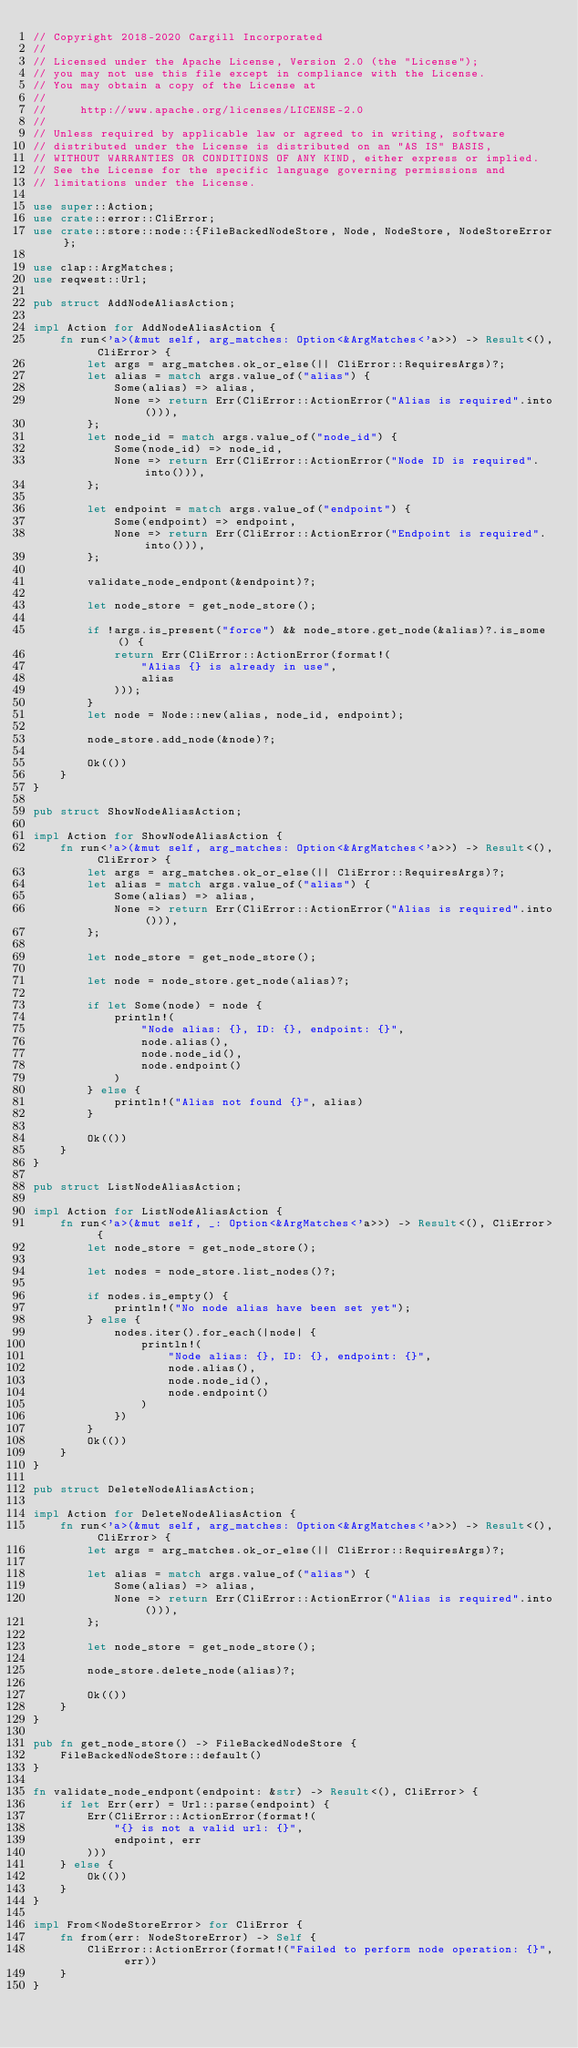<code> <loc_0><loc_0><loc_500><loc_500><_Rust_>// Copyright 2018-2020 Cargill Incorporated
//
// Licensed under the Apache License, Version 2.0 (the "License");
// you may not use this file except in compliance with the License.
// You may obtain a copy of the License at
//
//     http://www.apache.org/licenses/LICENSE-2.0
//
// Unless required by applicable law or agreed to in writing, software
// distributed under the License is distributed on an "AS IS" BASIS,
// WITHOUT WARRANTIES OR CONDITIONS OF ANY KIND, either express or implied.
// See the License for the specific language governing permissions and
// limitations under the License.

use super::Action;
use crate::error::CliError;
use crate::store::node::{FileBackedNodeStore, Node, NodeStore, NodeStoreError};

use clap::ArgMatches;
use reqwest::Url;

pub struct AddNodeAliasAction;

impl Action for AddNodeAliasAction {
    fn run<'a>(&mut self, arg_matches: Option<&ArgMatches<'a>>) -> Result<(), CliError> {
        let args = arg_matches.ok_or_else(|| CliError::RequiresArgs)?;
        let alias = match args.value_of("alias") {
            Some(alias) => alias,
            None => return Err(CliError::ActionError("Alias is required".into())),
        };
        let node_id = match args.value_of("node_id") {
            Some(node_id) => node_id,
            None => return Err(CliError::ActionError("Node ID is required".into())),
        };

        let endpoint = match args.value_of("endpoint") {
            Some(endpoint) => endpoint,
            None => return Err(CliError::ActionError("Endpoint is required".into())),
        };

        validate_node_endpont(&endpoint)?;

        let node_store = get_node_store();

        if !args.is_present("force") && node_store.get_node(&alias)?.is_some() {
            return Err(CliError::ActionError(format!(
                "Alias {} is already in use",
                alias
            )));
        }
        let node = Node::new(alias, node_id, endpoint);

        node_store.add_node(&node)?;

        Ok(())
    }
}

pub struct ShowNodeAliasAction;

impl Action for ShowNodeAliasAction {
    fn run<'a>(&mut self, arg_matches: Option<&ArgMatches<'a>>) -> Result<(), CliError> {
        let args = arg_matches.ok_or_else(|| CliError::RequiresArgs)?;
        let alias = match args.value_of("alias") {
            Some(alias) => alias,
            None => return Err(CliError::ActionError("Alias is required".into())),
        };

        let node_store = get_node_store();

        let node = node_store.get_node(alias)?;

        if let Some(node) = node {
            println!(
                "Node alias: {}, ID: {}, endpoint: {}",
                node.alias(),
                node.node_id(),
                node.endpoint()
            )
        } else {
            println!("Alias not found {}", alias)
        }

        Ok(())
    }
}

pub struct ListNodeAliasAction;

impl Action for ListNodeAliasAction {
    fn run<'a>(&mut self, _: Option<&ArgMatches<'a>>) -> Result<(), CliError> {
        let node_store = get_node_store();

        let nodes = node_store.list_nodes()?;

        if nodes.is_empty() {
            println!("No node alias have been set yet");
        } else {
            nodes.iter().for_each(|node| {
                println!(
                    "Node alias: {}, ID: {}, endpoint: {}",
                    node.alias(),
                    node.node_id(),
                    node.endpoint()
                )
            })
        }
        Ok(())
    }
}

pub struct DeleteNodeAliasAction;

impl Action for DeleteNodeAliasAction {
    fn run<'a>(&mut self, arg_matches: Option<&ArgMatches<'a>>) -> Result<(), CliError> {
        let args = arg_matches.ok_or_else(|| CliError::RequiresArgs)?;

        let alias = match args.value_of("alias") {
            Some(alias) => alias,
            None => return Err(CliError::ActionError("Alias is required".into())),
        };

        let node_store = get_node_store();

        node_store.delete_node(alias)?;

        Ok(())
    }
}

pub fn get_node_store() -> FileBackedNodeStore {
    FileBackedNodeStore::default()
}

fn validate_node_endpont(endpoint: &str) -> Result<(), CliError> {
    if let Err(err) = Url::parse(endpoint) {
        Err(CliError::ActionError(format!(
            "{} is not a valid url: {}",
            endpoint, err
        )))
    } else {
        Ok(())
    }
}

impl From<NodeStoreError> for CliError {
    fn from(err: NodeStoreError) -> Self {
        CliError::ActionError(format!("Failed to perform node operation: {}", err))
    }
}
</code> 